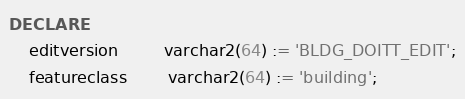<code> <loc_0><loc_0><loc_500><loc_500><_SQL_>DECLARE
    editversion         varchar2(64) := 'BLDG_DOITT_EDIT';
    featureclass        varchar2(64) := 'building';</code> 